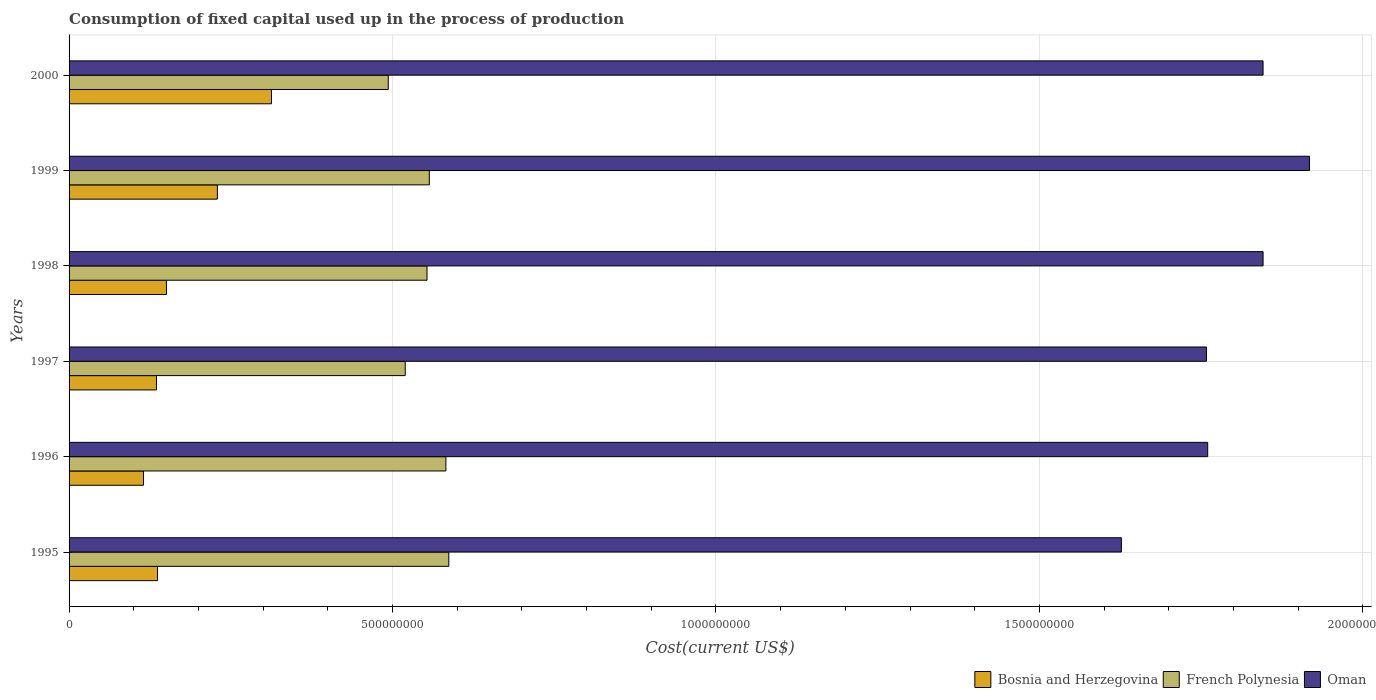Are the number of bars per tick equal to the number of legend labels?
Make the answer very short. Yes. What is the label of the 4th group of bars from the top?
Give a very brief answer. 1997. In how many cases, is the number of bars for a given year not equal to the number of legend labels?
Ensure brevity in your answer.  0. What is the amount consumed in the process of production in French Polynesia in 1998?
Offer a very short reply. 5.53e+08. Across all years, what is the maximum amount consumed in the process of production in Oman?
Ensure brevity in your answer.  1.92e+09. Across all years, what is the minimum amount consumed in the process of production in Oman?
Keep it short and to the point. 1.63e+09. In which year was the amount consumed in the process of production in French Polynesia minimum?
Give a very brief answer. 2000. What is the total amount consumed in the process of production in Oman in the graph?
Make the answer very short. 1.08e+1. What is the difference between the amount consumed in the process of production in French Polynesia in 1999 and that in 2000?
Provide a succinct answer. 6.35e+07. What is the difference between the amount consumed in the process of production in Oman in 2000 and the amount consumed in the process of production in French Polynesia in 1999?
Offer a terse response. 1.29e+09. What is the average amount consumed in the process of production in Bosnia and Herzegovina per year?
Keep it short and to the point. 1.80e+08. In the year 1995, what is the difference between the amount consumed in the process of production in Oman and amount consumed in the process of production in French Polynesia?
Provide a succinct answer. 1.04e+09. What is the ratio of the amount consumed in the process of production in Oman in 1996 to that in 2000?
Provide a succinct answer. 0.95. What is the difference between the highest and the second highest amount consumed in the process of production in Oman?
Offer a very short reply. 7.17e+07. What is the difference between the highest and the lowest amount consumed in the process of production in Oman?
Keep it short and to the point. 2.91e+08. In how many years, is the amount consumed in the process of production in Bosnia and Herzegovina greater than the average amount consumed in the process of production in Bosnia and Herzegovina taken over all years?
Ensure brevity in your answer.  2. Is the sum of the amount consumed in the process of production in Bosnia and Herzegovina in 1996 and 1997 greater than the maximum amount consumed in the process of production in French Polynesia across all years?
Offer a terse response. No. What does the 2nd bar from the top in 1995 represents?
Offer a very short reply. French Polynesia. What does the 2nd bar from the bottom in 1995 represents?
Your response must be concise. French Polynesia. Is it the case that in every year, the sum of the amount consumed in the process of production in Bosnia and Herzegovina and amount consumed in the process of production in Oman is greater than the amount consumed in the process of production in French Polynesia?
Your answer should be compact. Yes. How many bars are there?
Your response must be concise. 18. How many years are there in the graph?
Make the answer very short. 6. What is the difference between two consecutive major ticks on the X-axis?
Give a very brief answer. 5.00e+08. Are the values on the major ticks of X-axis written in scientific E-notation?
Provide a short and direct response. No. Does the graph contain any zero values?
Make the answer very short. No. Where does the legend appear in the graph?
Provide a succinct answer. Bottom right. How many legend labels are there?
Your answer should be very brief. 3. How are the legend labels stacked?
Make the answer very short. Horizontal. What is the title of the graph?
Your answer should be very brief. Consumption of fixed capital used up in the process of production. What is the label or title of the X-axis?
Ensure brevity in your answer.  Cost(current US$). What is the Cost(current US$) of Bosnia and Herzegovina in 1995?
Provide a short and direct response. 1.37e+08. What is the Cost(current US$) of French Polynesia in 1995?
Keep it short and to the point. 5.87e+08. What is the Cost(current US$) of Oman in 1995?
Your response must be concise. 1.63e+09. What is the Cost(current US$) of Bosnia and Herzegovina in 1996?
Offer a very short reply. 1.15e+08. What is the Cost(current US$) of French Polynesia in 1996?
Keep it short and to the point. 5.83e+08. What is the Cost(current US$) in Oman in 1996?
Make the answer very short. 1.76e+09. What is the Cost(current US$) of Bosnia and Herzegovina in 1997?
Make the answer very short. 1.35e+08. What is the Cost(current US$) in French Polynesia in 1997?
Offer a very short reply. 5.20e+08. What is the Cost(current US$) in Oman in 1997?
Give a very brief answer. 1.76e+09. What is the Cost(current US$) in Bosnia and Herzegovina in 1998?
Your answer should be compact. 1.51e+08. What is the Cost(current US$) in French Polynesia in 1998?
Offer a terse response. 5.53e+08. What is the Cost(current US$) of Oman in 1998?
Ensure brevity in your answer.  1.85e+09. What is the Cost(current US$) of Bosnia and Herzegovina in 1999?
Provide a short and direct response. 2.29e+08. What is the Cost(current US$) in French Polynesia in 1999?
Keep it short and to the point. 5.57e+08. What is the Cost(current US$) of Oman in 1999?
Make the answer very short. 1.92e+09. What is the Cost(current US$) of Bosnia and Herzegovina in 2000?
Offer a terse response. 3.13e+08. What is the Cost(current US$) of French Polynesia in 2000?
Provide a short and direct response. 4.93e+08. What is the Cost(current US$) of Oman in 2000?
Make the answer very short. 1.85e+09. Across all years, what is the maximum Cost(current US$) of Bosnia and Herzegovina?
Provide a succinct answer. 3.13e+08. Across all years, what is the maximum Cost(current US$) in French Polynesia?
Offer a terse response. 5.87e+08. Across all years, what is the maximum Cost(current US$) of Oman?
Provide a short and direct response. 1.92e+09. Across all years, what is the minimum Cost(current US$) in Bosnia and Herzegovina?
Your answer should be very brief. 1.15e+08. Across all years, what is the minimum Cost(current US$) in French Polynesia?
Keep it short and to the point. 4.93e+08. Across all years, what is the minimum Cost(current US$) in Oman?
Your answer should be very brief. 1.63e+09. What is the total Cost(current US$) of Bosnia and Herzegovina in the graph?
Provide a short and direct response. 1.08e+09. What is the total Cost(current US$) in French Polynesia in the graph?
Your response must be concise. 3.29e+09. What is the total Cost(current US$) of Oman in the graph?
Keep it short and to the point. 1.08e+1. What is the difference between the Cost(current US$) of Bosnia and Herzegovina in 1995 and that in 1996?
Keep it short and to the point. 2.17e+07. What is the difference between the Cost(current US$) of French Polynesia in 1995 and that in 1996?
Provide a succinct answer. 4.51e+06. What is the difference between the Cost(current US$) in Oman in 1995 and that in 1996?
Your answer should be compact. -1.33e+08. What is the difference between the Cost(current US$) in Bosnia and Herzegovina in 1995 and that in 1997?
Give a very brief answer. 1.60e+06. What is the difference between the Cost(current US$) of French Polynesia in 1995 and that in 1997?
Keep it short and to the point. 6.74e+07. What is the difference between the Cost(current US$) in Oman in 1995 and that in 1997?
Keep it short and to the point. -1.32e+08. What is the difference between the Cost(current US$) in Bosnia and Herzegovina in 1995 and that in 1998?
Your answer should be very brief. -1.38e+07. What is the difference between the Cost(current US$) in French Polynesia in 1995 and that in 1998?
Provide a short and direct response. 3.37e+07. What is the difference between the Cost(current US$) of Oman in 1995 and that in 1998?
Give a very brief answer. -2.19e+08. What is the difference between the Cost(current US$) of Bosnia and Herzegovina in 1995 and that in 1999?
Give a very brief answer. -9.25e+07. What is the difference between the Cost(current US$) in French Polynesia in 1995 and that in 1999?
Give a very brief answer. 3.01e+07. What is the difference between the Cost(current US$) of Oman in 1995 and that in 1999?
Offer a very short reply. -2.91e+08. What is the difference between the Cost(current US$) of Bosnia and Herzegovina in 1995 and that in 2000?
Give a very brief answer. -1.76e+08. What is the difference between the Cost(current US$) in French Polynesia in 1995 and that in 2000?
Provide a succinct answer. 9.36e+07. What is the difference between the Cost(current US$) in Oman in 1995 and that in 2000?
Offer a terse response. -2.19e+08. What is the difference between the Cost(current US$) in Bosnia and Herzegovina in 1996 and that in 1997?
Offer a very short reply. -2.01e+07. What is the difference between the Cost(current US$) of French Polynesia in 1996 and that in 1997?
Make the answer very short. 6.28e+07. What is the difference between the Cost(current US$) of Oman in 1996 and that in 1997?
Your response must be concise. 1.84e+06. What is the difference between the Cost(current US$) in Bosnia and Herzegovina in 1996 and that in 1998?
Offer a terse response. -3.55e+07. What is the difference between the Cost(current US$) in French Polynesia in 1996 and that in 1998?
Your answer should be compact. 2.92e+07. What is the difference between the Cost(current US$) in Oman in 1996 and that in 1998?
Offer a very short reply. -8.56e+07. What is the difference between the Cost(current US$) of Bosnia and Herzegovina in 1996 and that in 1999?
Your answer should be compact. -1.14e+08. What is the difference between the Cost(current US$) of French Polynesia in 1996 and that in 1999?
Offer a terse response. 2.56e+07. What is the difference between the Cost(current US$) of Oman in 1996 and that in 1999?
Provide a succinct answer. -1.57e+08. What is the difference between the Cost(current US$) of Bosnia and Herzegovina in 1996 and that in 2000?
Offer a very short reply. -1.98e+08. What is the difference between the Cost(current US$) in French Polynesia in 1996 and that in 2000?
Your response must be concise. 8.91e+07. What is the difference between the Cost(current US$) of Oman in 1996 and that in 2000?
Offer a very short reply. -8.56e+07. What is the difference between the Cost(current US$) in Bosnia and Herzegovina in 1997 and that in 1998?
Your answer should be very brief. -1.54e+07. What is the difference between the Cost(current US$) in French Polynesia in 1997 and that in 1998?
Keep it short and to the point. -3.37e+07. What is the difference between the Cost(current US$) of Oman in 1997 and that in 1998?
Ensure brevity in your answer.  -8.75e+07. What is the difference between the Cost(current US$) in Bosnia and Herzegovina in 1997 and that in 1999?
Your answer should be compact. -9.41e+07. What is the difference between the Cost(current US$) of French Polynesia in 1997 and that in 1999?
Your answer should be very brief. -3.72e+07. What is the difference between the Cost(current US$) in Oman in 1997 and that in 1999?
Your response must be concise. -1.59e+08. What is the difference between the Cost(current US$) of Bosnia and Herzegovina in 1997 and that in 2000?
Ensure brevity in your answer.  -1.78e+08. What is the difference between the Cost(current US$) of French Polynesia in 1997 and that in 2000?
Your answer should be very brief. 2.63e+07. What is the difference between the Cost(current US$) of Oman in 1997 and that in 2000?
Give a very brief answer. -8.74e+07. What is the difference between the Cost(current US$) in Bosnia and Herzegovina in 1998 and that in 1999?
Provide a short and direct response. -7.87e+07. What is the difference between the Cost(current US$) of French Polynesia in 1998 and that in 1999?
Make the answer very short. -3.55e+06. What is the difference between the Cost(current US$) in Oman in 1998 and that in 1999?
Provide a short and direct response. -7.17e+07. What is the difference between the Cost(current US$) in Bosnia and Herzegovina in 1998 and that in 2000?
Give a very brief answer. -1.62e+08. What is the difference between the Cost(current US$) in French Polynesia in 1998 and that in 2000?
Offer a very short reply. 5.99e+07. What is the difference between the Cost(current US$) of Oman in 1998 and that in 2000?
Keep it short and to the point. 4.22e+04. What is the difference between the Cost(current US$) of Bosnia and Herzegovina in 1999 and that in 2000?
Offer a terse response. -8.36e+07. What is the difference between the Cost(current US$) in French Polynesia in 1999 and that in 2000?
Offer a terse response. 6.35e+07. What is the difference between the Cost(current US$) in Oman in 1999 and that in 2000?
Offer a terse response. 7.18e+07. What is the difference between the Cost(current US$) in Bosnia and Herzegovina in 1995 and the Cost(current US$) in French Polynesia in 1996?
Ensure brevity in your answer.  -4.46e+08. What is the difference between the Cost(current US$) in Bosnia and Herzegovina in 1995 and the Cost(current US$) in Oman in 1996?
Keep it short and to the point. -1.62e+09. What is the difference between the Cost(current US$) in French Polynesia in 1995 and the Cost(current US$) in Oman in 1996?
Provide a short and direct response. -1.17e+09. What is the difference between the Cost(current US$) of Bosnia and Herzegovina in 1995 and the Cost(current US$) of French Polynesia in 1997?
Offer a terse response. -3.83e+08. What is the difference between the Cost(current US$) in Bosnia and Herzegovina in 1995 and the Cost(current US$) in Oman in 1997?
Provide a succinct answer. -1.62e+09. What is the difference between the Cost(current US$) in French Polynesia in 1995 and the Cost(current US$) in Oman in 1997?
Give a very brief answer. -1.17e+09. What is the difference between the Cost(current US$) of Bosnia and Herzegovina in 1995 and the Cost(current US$) of French Polynesia in 1998?
Make the answer very short. -4.17e+08. What is the difference between the Cost(current US$) of Bosnia and Herzegovina in 1995 and the Cost(current US$) of Oman in 1998?
Ensure brevity in your answer.  -1.71e+09. What is the difference between the Cost(current US$) in French Polynesia in 1995 and the Cost(current US$) in Oman in 1998?
Ensure brevity in your answer.  -1.26e+09. What is the difference between the Cost(current US$) of Bosnia and Herzegovina in 1995 and the Cost(current US$) of French Polynesia in 1999?
Keep it short and to the point. -4.20e+08. What is the difference between the Cost(current US$) of Bosnia and Herzegovina in 1995 and the Cost(current US$) of Oman in 1999?
Offer a very short reply. -1.78e+09. What is the difference between the Cost(current US$) of French Polynesia in 1995 and the Cost(current US$) of Oman in 1999?
Your answer should be very brief. -1.33e+09. What is the difference between the Cost(current US$) in Bosnia and Herzegovina in 1995 and the Cost(current US$) in French Polynesia in 2000?
Offer a terse response. -3.57e+08. What is the difference between the Cost(current US$) of Bosnia and Herzegovina in 1995 and the Cost(current US$) of Oman in 2000?
Your answer should be compact. -1.71e+09. What is the difference between the Cost(current US$) of French Polynesia in 1995 and the Cost(current US$) of Oman in 2000?
Make the answer very short. -1.26e+09. What is the difference between the Cost(current US$) in Bosnia and Herzegovina in 1996 and the Cost(current US$) in French Polynesia in 1997?
Keep it short and to the point. -4.05e+08. What is the difference between the Cost(current US$) in Bosnia and Herzegovina in 1996 and the Cost(current US$) in Oman in 1997?
Give a very brief answer. -1.64e+09. What is the difference between the Cost(current US$) of French Polynesia in 1996 and the Cost(current US$) of Oman in 1997?
Make the answer very short. -1.18e+09. What is the difference between the Cost(current US$) of Bosnia and Herzegovina in 1996 and the Cost(current US$) of French Polynesia in 1998?
Offer a terse response. -4.38e+08. What is the difference between the Cost(current US$) in Bosnia and Herzegovina in 1996 and the Cost(current US$) in Oman in 1998?
Ensure brevity in your answer.  -1.73e+09. What is the difference between the Cost(current US$) in French Polynesia in 1996 and the Cost(current US$) in Oman in 1998?
Give a very brief answer. -1.26e+09. What is the difference between the Cost(current US$) of Bosnia and Herzegovina in 1996 and the Cost(current US$) of French Polynesia in 1999?
Ensure brevity in your answer.  -4.42e+08. What is the difference between the Cost(current US$) of Bosnia and Herzegovina in 1996 and the Cost(current US$) of Oman in 1999?
Your response must be concise. -1.80e+09. What is the difference between the Cost(current US$) of French Polynesia in 1996 and the Cost(current US$) of Oman in 1999?
Provide a succinct answer. -1.33e+09. What is the difference between the Cost(current US$) in Bosnia and Herzegovina in 1996 and the Cost(current US$) in French Polynesia in 2000?
Provide a short and direct response. -3.78e+08. What is the difference between the Cost(current US$) in Bosnia and Herzegovina in 1996 and the Cost(current US$) in Oman in 2000?
Your response must be concise. -1.73e+09. What is the difference between the Cost(current US$) in French Polynesia in 1996 and the Cost(current US$) in Oman in 2000?
Give a very brief answer. -1.26e+09. What is the difference between the Cost(current US$) of Bosnia and Herzegovina in 1997 and the Cost(current US$) of French Polynesia in 1998?
Give a very brief answer. -4.18e+08. What is the difference between the Cost(current US$) in Bosnia and Herzegovina in 1997 and the Cost(current US$) in Oman in 1998?
Provide a short and direct response. -1.71e+09. What is the difference between the Cost(current US$) in French Polynesia in 1997 and the Cost(current US$) in Oman in 1998?
Provide a short and direct response. -1.33e+09. What is the difference between the Cost(current US$) of Bosnia and Herzegovina in 1997 and the Cost(current US$) of French Polynesia in 1999?
Provide a succinct answer. -4.22e+08. What is the difference between the Cost(current US$) in Bosnia and Herzegovina in 1997 and the Cost(current US$) in Oman in 1999?
Your answer should be compact. -1.78e+09. What is the difference between the Cost(current US$) of French Polynesia in 1997 and the Cost(current US$) of Oman in 1999?
Your response must be concise. -1.40e+09. What is the difference between the Cost(current US$) in Bosnia and Herzegovina in 1997 and the Cost(current US$) in French Polynesia in 2000?
Keep it short and to the point. -3.58e+08. What is the difference between the Cost(current US$) of Bosnia and Herzegovina in 1997 and the Cost(current US$) of Oman in 2000?
Offer a very short reply. -1.71e+09. What is the difference between the Cost(current US$) in French Polynesia in 1997 and the Cost(current US$) in Oman in 2000?
Your answer should be compact. -1.33e+09. What is the difference between the Cost(current US$) of Bosnia and Herzegovina in 1998 and the Cost(current US$) of French Polynesia in 1999?
Make the answer very short. -4.06e+08. What is the difference between the Cost(current US$) of Bosnia and Herzegovina in 1998 and the Cost(current US$) of Oman in 1999?
Your response must be concise. -1.77e+09. What is the difference between the Cost(current US$) of French Polynesia in 1998 and the Cost(current US$) of Oman in 1999?
Offer a very short reply. -1.36e+09. What is the difference between the Cost(current US$) of Bosnia and Herzegovina in 1998 and the Cost(current US$) of French Polynesia in 2000?
Offer a terse response. -3.43e+08. What is the difference between the Cost(current US$) of Bosnia and Herzegovina in 1998 and the Cost(current US$) of Oman in 2000?
Provide a succinct answer. -1.70e+09. What is the difference between the Cost(current US$) in French Polynesia in 1998 and the Cost(current US$) in Oman in 2000?
Your answer should be compact. -1.29e+09. What is the difference between the Cost(current US$) in Bosnia and Herzegovina in 1999 and the Cost(current US$) in French Polynesia in 2000?
Ensure brevity in your answer.  -2.64e+08. What is the difference between the Cost(current US$) in Bosnia and Herzegovina in 1999 and the Cost(current US$) in Oman in 2000?
Your answer should be very brief. -1.62e+09. What is the difference between the Cost(current US$) in French Polynesia in 1999 and the Cost(current US$) in Oman in 2000?
Give a very brief answer. -1.29e+09. What is the average Cost(current US$) of Bosnia and Herzegovina per year?
Your answer should be compact. 1.80e+08. What is the average Cost(current US$) of French Polynesia per year?
Keep it short and to the point. 5.49e+08. What is the average Cost(current US$) of Oman per year?
Offer a terse response. 1.79e+09. In the year 1995, what is the difference between the Cost(current US$) of Bosnia and Herzegovina and Cost(current US$) of French Polynesia?
Offer a very short reply. -4.50e+08. In the year 1995, what is the difference between the Cost(current US$) of Bosnia and Herzegovina and Cost(current US$) of Oman?
Ensure brevity in your answer.  -1.49e+09. In the year 1995, what is the difference between the Cost(current US$) in French Polynesia and Cost(current US$) in Oman?
Keep it short and to the point. -1.04e+09. In the year 1996, what is the difference between the Cost(current US$) of Bosnia and Herzegovina and Cost(current US$) of French Polynesia?
Your answer should be very brief. -4.67e+08. In the year 1996, what is the difference between the Cost(current US$) in Bosnia and Herzegovina and Cost(current US$) in Oman?
Offer a very short reply. -1.65e+09. In the year 1996, what is the difference between the Cost(current US$) in French Polynesia and Cost(current US$) in Oman?
Your response must be concise. -1.18e+09. In the year 1997, what is the difference between the Cost(current US$) in Bosnia and Herzegovina and Cost(current US$) in French Polynesia?
Offer a terse response. -3.85e+08. In the year 1997, what is the difference between the Cost(current US$) of Bosnia and Herzegovina and Cost(current US$) of Oman?
Your response must be concise. -1.62e+09. In the year 1997, what is the difference between the Cost(current US$) of French Polynesia and Cost(current US$) of Oman?
Your response must be concise. -1.24e+09. In the year 1998, what is the difference between the Cost(current US$) of Bosnia and Herzegovina and Cost(current US$) of French Polynesia?
Your answer should be very brief. -4.03e+08. In the year 1998, what is the difference between the Cost(current US$) of Bosnia and Herzegovina and Cost(current US$) of Oman?
Your answer should be very brief. -1.70e+09. In the year 1998, what is the difference between the Cost(current US$) in French Polynesia and Cost(current US$) in Oman?
Provide a short and direct response. -1.29e+09. In the year 1999, what is the difference between the Cost(current US$) in Bosnia and Herzegovina and Cost(current US$) in French Polynesia?
Give a very brief answer. -3.28e+08. In the year 1999, what is the difference between the Cost(current US$) of Bosnia and Herzegovina and Cost(current US$) of Oman?
Ensure brevity in your answer.  -1.69e+09. In the year 1999, what is the difference between the Cost(current US$) in French Polynesia and Cost(current US$) in Oman?
Ensure brevity in your answer.  -1.36e+09. In the year 2000, what is the difference between the Cost(current US$) in Bosnia and Herzegovina and Cost(current US$) in French Polynesia?
Your answer should be compact. -1.81e+08. In the year 2000, what is the difference between the Cost(current US$) of Bosnia and Herzegovina and Cost(current US$) of Oman?
Give a very brief answer. -1.53e+09. In the year 2000, what is the difference between the Cost(current US$) of French Polynesia and Cost(current US$) of Oman?
Keep it short and to the point. -1.35e+09. What is the ratio of the Cost(current US$) of Bosnia and Herzegovina in 1995 to that in 1996?
Provide a succinct answer. 1.19. What is the ratio of the Cost(current US$) of French Polynesia in 1995 to that in 1996?
Offer a terse response. 1.01. What is the ratio of the Cost(current US$) in Oman in 1995 to that in 1996?
Make the answer very short. 0.92. What is the ratio of the Cost(current US$) of Bosnia and Herzegovina in 1995 to that in 1997?
Keep it short and to the point. 1.01. What is the ratio of the Cost(current US$) of French Polynesia in 1995 to that in 1997?
Offer a very short reply. 1.13. What is the ratio of the Cost(current US$) in Oman in 1995 to that in 1997?
Offer a very short reply. 0.93. What is the ratio of the Cost(current US$) in Bosnia and Herzegovina in 1995 to that in 1998?
Your response must be concise. 0.91. What is the ratio of the Cost(current US$) in French Polynesia in 1995 to that in 1998?
Make the answer very short. 1.06. What is the ratio of the Cost(current US$) of Oman in 1995 to that in 1998?
Your answer should be very brief. 0.88. What is the ratio of the Cost(current US$) in Bosnia and Herzegovina in 1995 to that in 1999?
Offer a terse response. 0.6. What is the ratio of the Cost(current US$) in French Polynesia in 1995 to that in 1999?
Keep it short and to the point. 1.05. What is the ratio of the Cost(current US$) of Oman in 1995 to that in 1999?
Provide a short and direct response. 0.85. What is the ratio of the Cost(current US$) in Bosnia and Herzegovina in 1995 to that in 2000?
Your answer should be compact. 0.44. What is the ratio of the Cost(current US$) of French Polynesia in 1995 to that in 2000?
Your response must be concise. 1.19. What is the ratio of the Cost(current US$) in Oman in 1995 to that in 2000?
Make the answer very short. 0.88. What is the ratio of the Cost(current US$) in Bosnia and Herzegovina in 1996 to that in 1997?
Your answer should be very brief. 0.85. What is the ratio of the Cost(current US$) of French Polynesia in 1996 to that in 1997?
Give a very brief answer. 1.12. What is the ratio of the Cost(current US$) of Bosnia and Herzegovina in 1996 to that in 1998?
Offer a very short reply. 0.76. What is the ratio of the Cost(current US$) in French Polynesia in 1996 to that in 1998?
Offer a very short reply. 1.05. What is the ratio of the Cost(current US$) of Oman in 1996 to that in 1998?
Your answer should be very brief. 0.95. What is the ratio of the Cost(current US$) of Bosnia and Herzegovina in 1996 to that in 1999?
Give a very brief answer. 0.5. What is the ratio of the Cost(current US$) of French Polynesia in 1996 to that in 1999?
Ensure brevity in your answer.  1.05. What is the ratio of the Cost(current US$) in Oman in 1996 to that in 1999?
Make the answer very short. 0.92. What is the ratio of the Cost(current US$) of Bosnia and Herzegovina in 1996 to that in 2000?
Ensure brevity in your answer.  0.37. What is the ratio of the Cost(current US$) of French Polynesia in 1996 to that in 2000?
Your answer should be very brief. 1.18. What is the ratio of the Cost(current US$) of Oman in 1996 to that in 2000?
Give a very brief answer. 0.95. What is the ratio of the Cost(current US$) of Bosnia and Herzegovina in 1997 to that in 1998?
Your answer should be compact. 0.9. What is the ratio of the Cost(current US$) of French Polynesia in 1997 to that in 1998?
Offer a terse response. 0.94. What is the ratio of the Cost(current US$) of Oman in 1997 to that in 1998?
Provide a succinct answer. 0.95. What is the ratio of the Cost(current US$) of Bosnia and Herzegovina in 1997 to that in 1999?
Make the answer very short. 0.59. What is the ratio of the Cost(current US$) in French Polynesia in 1997 to that in 1999?
Give a very brief answer. 0.93. What is the ratio of the Cost(current US$) in Oman in 1997 to that in 1999?
Provide a short and direct response. 0.92. What is the ratio of the Cost(current US$) of Bosnia and Herzegovina in 1997 to that in 2000?
Provide a short and direct response. 0.43. What is the ratio of the Cost(current US$) of French Polynesia in 1997 to that in 2000?
Offer a terse response. 1.05. What is the ratio of the Cost(current US$) in Oman in 1997 to that in 2000?
Your answer should be compact. 0.95. What is the ratio of the Cost(current US$) of Bosnia and Herzegovina in 1998 to that in 1999?
Provide a succinct answer. 0.66. What is the ratio of the Cost(current US$) of Oman in 1998 to that in 1999?
Give a very brief answer. 0.96. What is the ratio of the Cost(current US$) of Bosnia and Herzegovina in 1998 to that in 2000?
Provide a succinct answer. 0.48. What is the ratio of the Cost(current US$) of French Polynesia in 1998 to that in 2000?
Offer a terse response. 1.12. What is the ratio of the Cost(current US$) of Oman in 1998 to that in 2000?
Provide a short and direct response. 1. What is the ratio of the Cost(current US$) in Bosnia and Herzegovina in 1999 to that in 2000?
Make the answer very short. 0.73. What is the ratio of the Cost(current US$) of French Polynesia in 1999 to that in 2000?
Provide a short and direct response. 1.13. What is the ratio of the Cost(current US$) of Oman in 1999 to that in 2000?
Provide a succinct answer. 1.04. What is the difference between the highest and the second highest Cost(current US$) of Bosnia and Herzegovina?
Make the answer very short. 8.36e+07. What is the difference between the highest and the second highest Cost(current US$) in French Polynesia?
Give a very brief answer. 4.51e+06. What is the difference between the highest and the second highest Cost(current US$) of Oman?
Your answer should be very brief. 7.17e+07. What is the difference between the highest and the lowest Cost(current US$) in Bosnia and Herzegovina?
Make the answer very short. 1.98e+08. What is the difference between the highest and the lowest Cost(current US$) of French Polynesia?
Make the answer very short. 9.36e+07. What is the difference between the highest and the lowest Cost(current US$) in Oman?
Provide a succinct answer. 2.91e+08. 